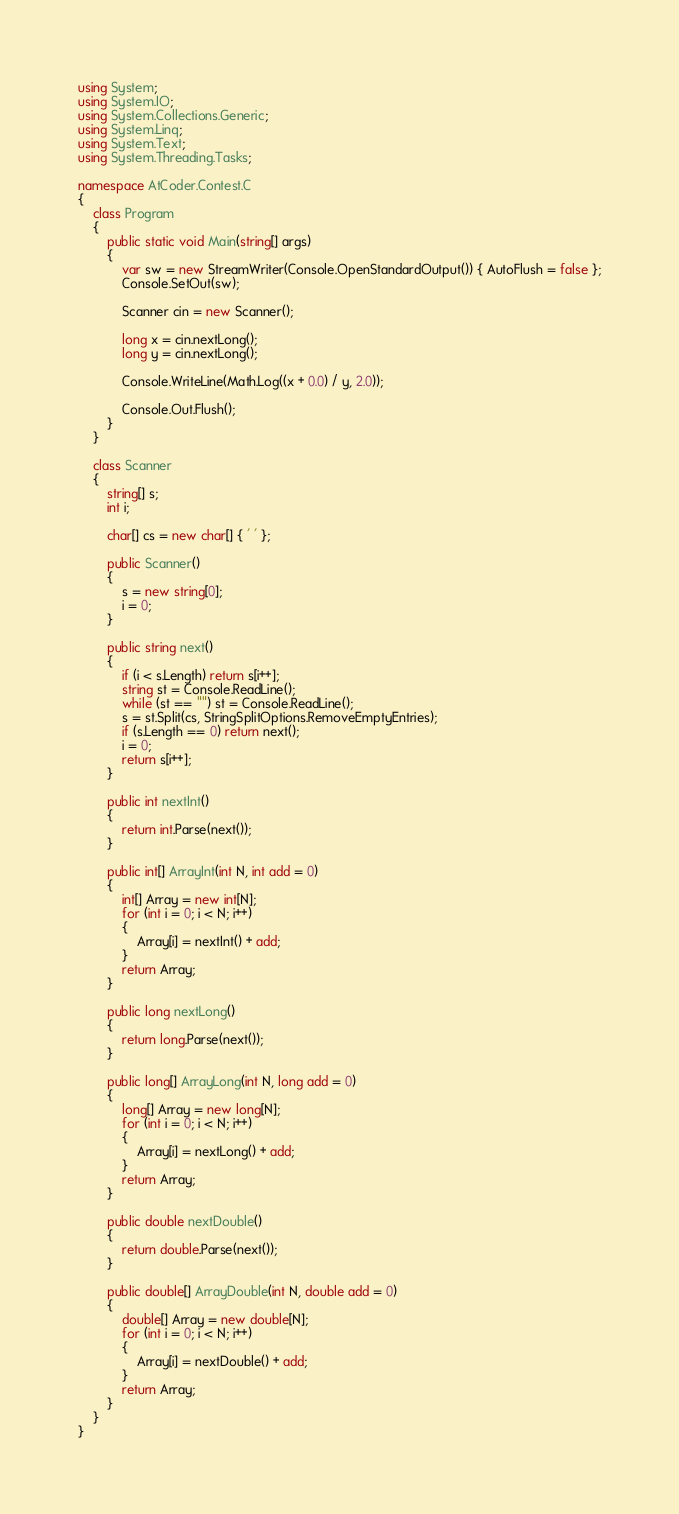Convert code to text. <code><loc_0><loc_0><loc_500><loc_500><_C#_>using System;
using System.IO;
using System.Collections.Generic;
using System.Linq;
using System.Text;
using System.Threading.Tasks;

namespace AtCoder.Contest.C
{
	class Program
	{
		public static void Main(string[] args)
		{
			var sw = new StreamWriter(Console.OpenStandardOutput()) { AutoFlush = false };
			Console.SetOut(sw);

			Scanner cin = new Scanner();

			long x = cin.nextLong();
			long y = cin.nextLong();

			Console.WriteLine(Math.Log((x + 0.0) / y, 2.0));

			Console.Out.Flush();
		}
	}

	class Scanner
	{
		string[] s;
		int i;

		char[] cs = new char[] { ' ' };

		public Scanner()
		{
			s = new string[0];
			i = 0;
		}

		public string next()
		{
			if (i < s.Length) return s[i++];
			string st = Console.ReadLine();
			while (st == "") st = Console.ReadLine();
			s = st.Split(cs, StringSplitOptions.RemoveEmptyEntries);
			if (s.Length == 0) return next();
			i = 0;
			return s[i++];
		}

		public int nextInt()
		{
			return int.Parse(next());
		}

		public int[] ArrayInt(int N, int add = 0)
		{
			int[] Array = new int[N];
			for (int i = 0; i < N; i++)
			{
				Array[i] = nextInt() + add;
			}
			return Array;
		}

		public long nextLong()
		{
			return long.Parse(next());
		}

		public long[] ArrayLong(int N, long add = 0)
		{
			long[] Array = new long[N];
			for (int i = 0; i < N; i++)
			{
				Array[i] = nextLong() + add;
			}
			return Array;
		}

		public double nextDouble()
		{
			return double.Parse(next());
		}

		public double[] ArrayDouble(int N, double add = 0)
		{
			double[] Array = new double[N];
			for (int i = 0; i < N; i++)
			{
				Array[i] = nextDouble() + add;
			}
			return Array;
		}
	}
}</code> 